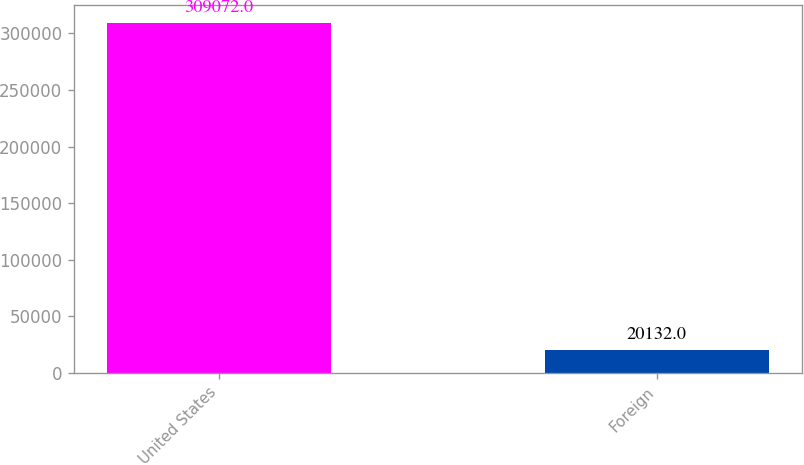<chart> <loc_0><loc_0><loc_500><loc_500><bar_chart><fcel>United States<fcel>Foreign<nl><fcel>309072<fcel>20132<nl></chart> 